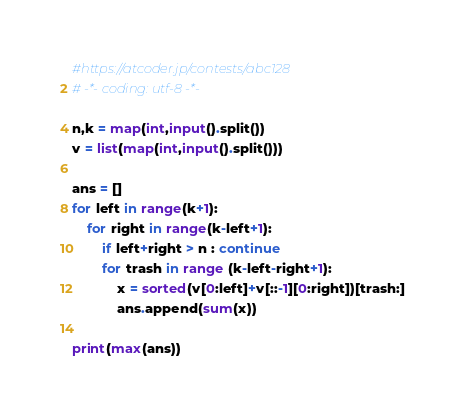<code> <loc_0><loc_0><loc_500><loc_500><_Python_>#https://atcoder.jp/contests/abc128
# -*- coding: utf-8 -*-

n,k = map(int,input().split())
v = list(map(int,input().split()))

ans = []
for left in range(k+1):
    for right in range(k-left+1):
        if left+right > n : continue
        for trash in range (k-left-right+1):
            x = sorted(v[0:left]+v[::-1][0:right])[trash:]
            ans.append(sum(x))

print(max(ans))</code> 